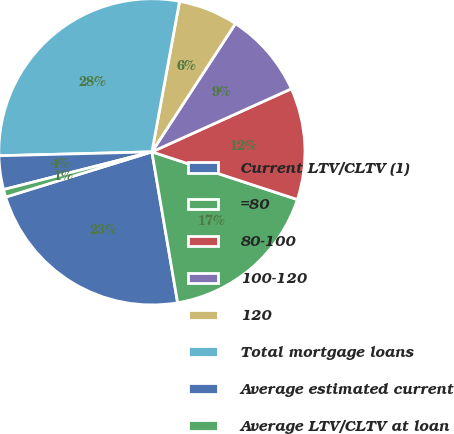<chart> <loc_0><loc_0><loc_500><loc_500><pie_chart><fcel>Current LTV/CLTV (1)<fcel>=80<fcel>80-100<fcel>100-120<fcel>120<fcel>Total mortgage loans<fcel>Average estimated current<fcel>Average LTV/CLTV at loan<nl><fcel>22.91%<fcel>17.27%<fcel>11.8%<fcel>9.05%<fcel>6.3%<fcel>28.29%<fcel>3.56%<fcel>0.81%<nl></chart> 